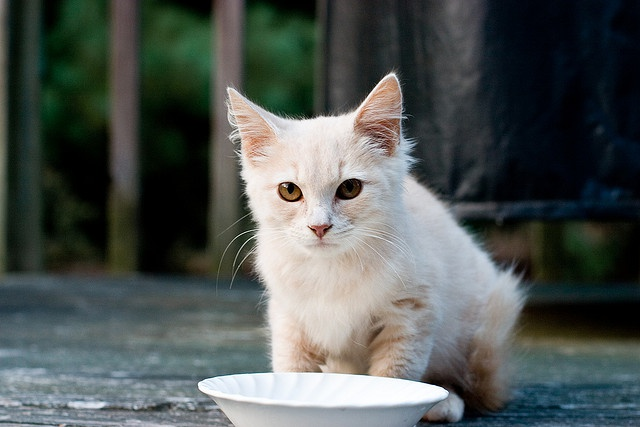Describe the objects in this image and their specific colors. I can see cat in gray, lightgray, darkgray, and black tones and bowl in gray, white, and darkgray tones in this image. 